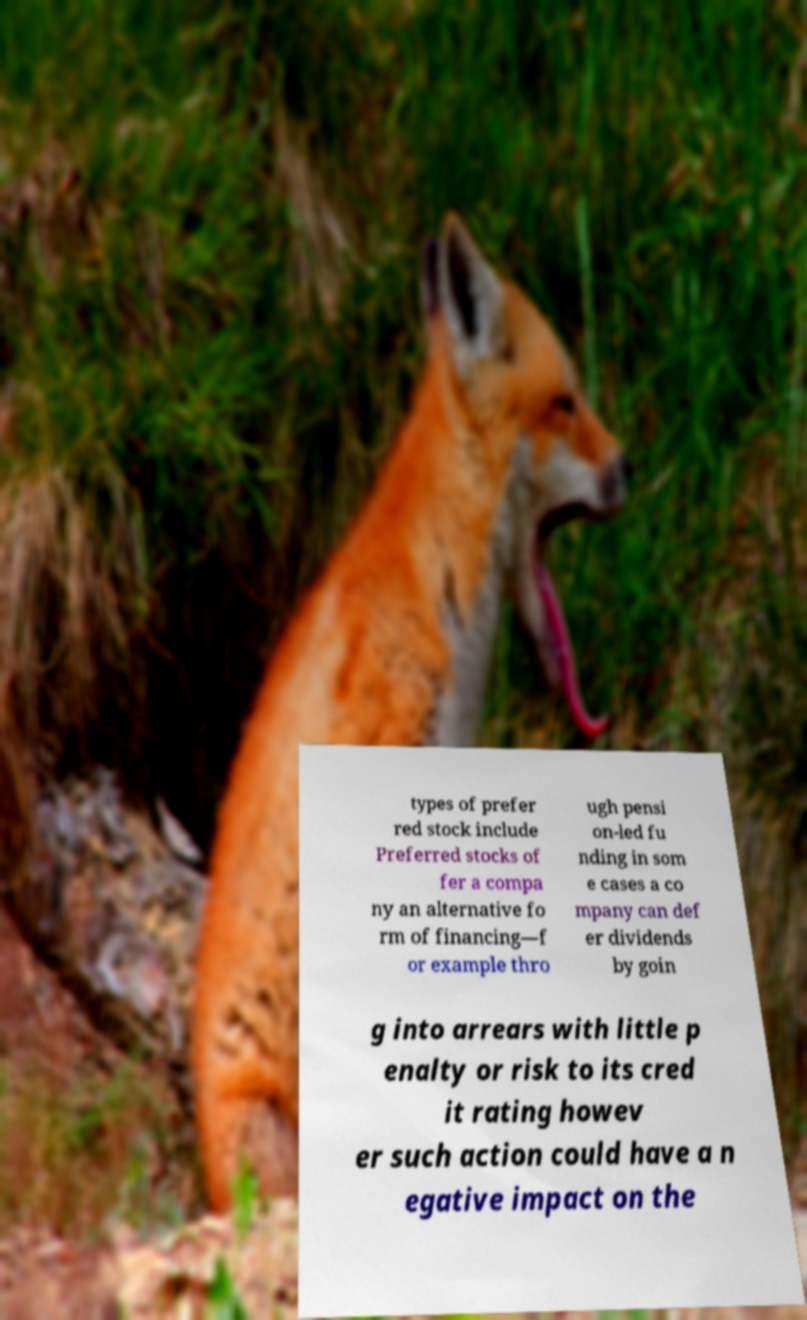Can you accurately transcribe the text from the provided image for me? types of prefer red stock include Preferred stocks of fer a compa ny an alternative fo rm of financing—f or example thro ugh pensi on-led fu nding in som e cases a co mpany can def er dividends by goin g into arrears with little p enalty or risk to its cred it rating howev er such action could have a n egative impact on the 